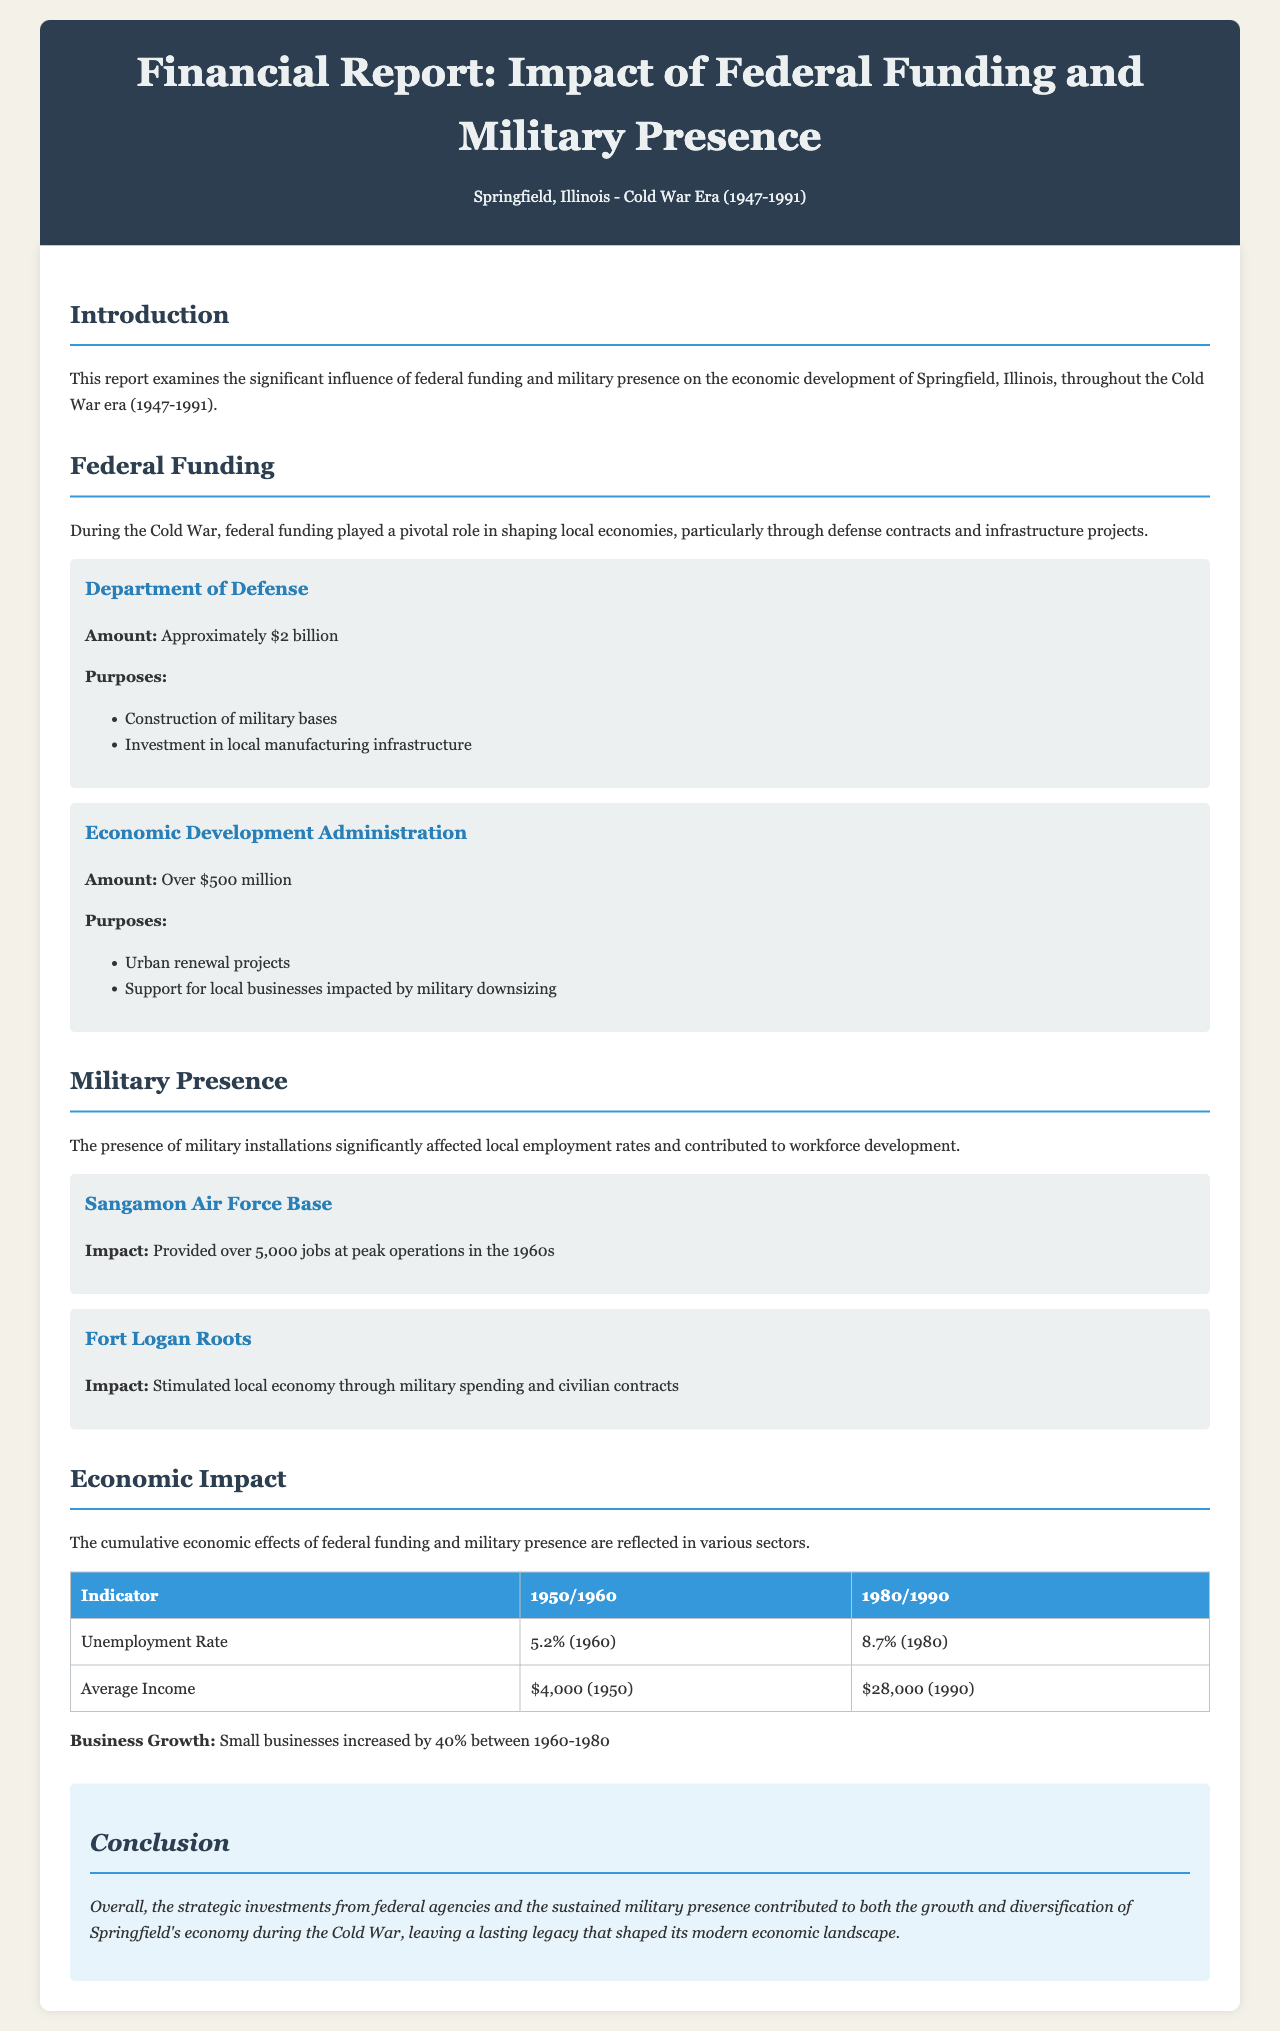What was the total federal funding from the Department of Defense? The document states that the total federal funding from the Department of Defense was approximately $2 billion.
Answer: Approximately $2 billion What was the economic impact on unemployment rate in 1980? The unemployment rate was noted as 8.7% in the document for the year 1980.
Answer: 8.7% What percentage did small businesses increase between 1960 and 1980? The document mentions that small businesses increased by 40% during that time period.
Answer: 40% What military base provided over 5,000 jobs at peak operations? The document identifies Sangamon Air Force Base as providing over 5,000 jobs at peak operations in the 1960s.
Answer: Sangamon Air Force Base How much funding did the Economic Development Administration provide? The document states that the Economic Development Administration provided over $500 million in funding.
Answer: Over $500 million What was the average income in 1990? The document indicates that the average income in 1990 was $28,000.
Answer: $28,000 Why did Fort Logan Roots stimulate the local economy? The document explains that Fort Logan Roots stimulated the local economy through military spending and civilian contracts.
Answer: Military spending and civilian contracts What was the unemployment rate in 1960? The unemployment rate in 1960 was 5.2% as noted in the document.
Answer: 5.2% What sector did federal funding primarily influence? The document highlights that federal funding primarily influenced the local economies through defense contracts and infrastructure projects.
Answer: Local economies 